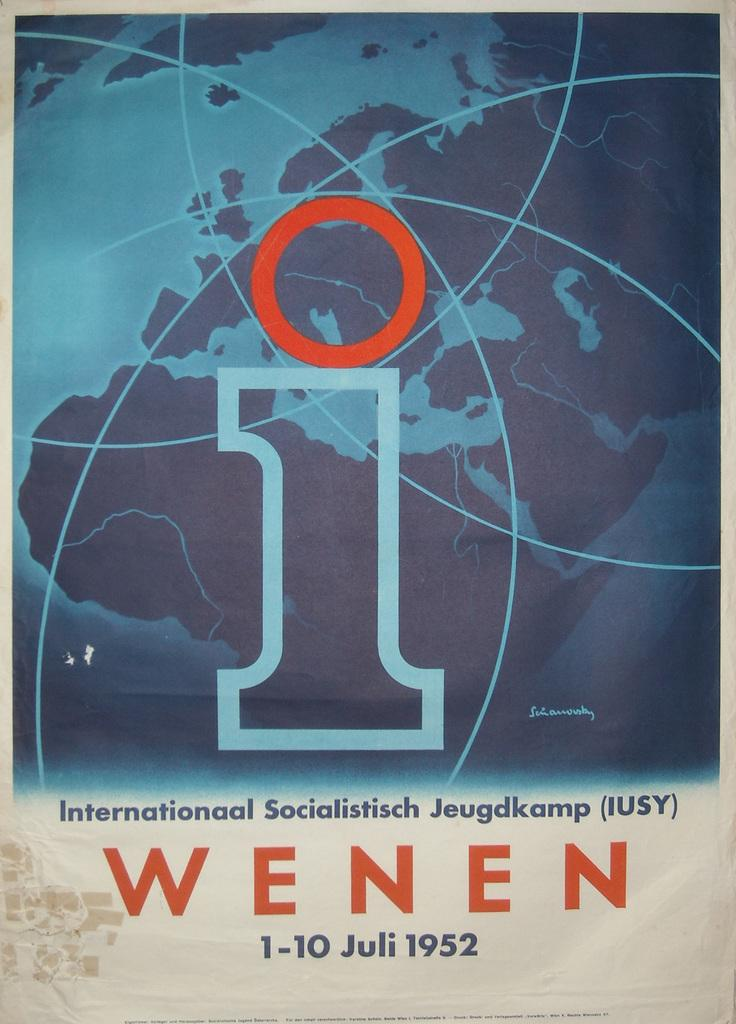What is featured on the poster in the image? The poster contains a map. What else can be found on the poster besides the map? There is text on the poster. What type of tax is being discussed on the poster? There is no mention of tax on the poster; it contains a map and text. How does the bone affect the map on the poster? There is no bone present on the poster, and therefore it cannot affect the map. 